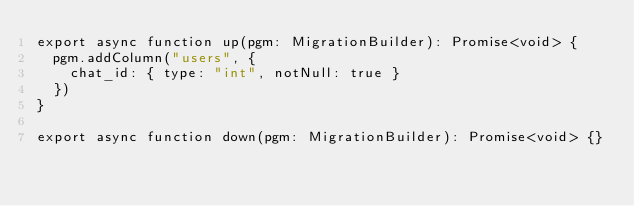Convert code to text. <code><loc_0><loc_0><loc_500><loc_500><_TypeScript_>export async function up(pgm: MigrationBuilder): Promise<void> {
  pgm.addColumn("users", {
    chat_id: { type: "int", notNull: true }
  })
}

export async function down(pgm: MigrationBuilder): Promise<void> {}
</code> 